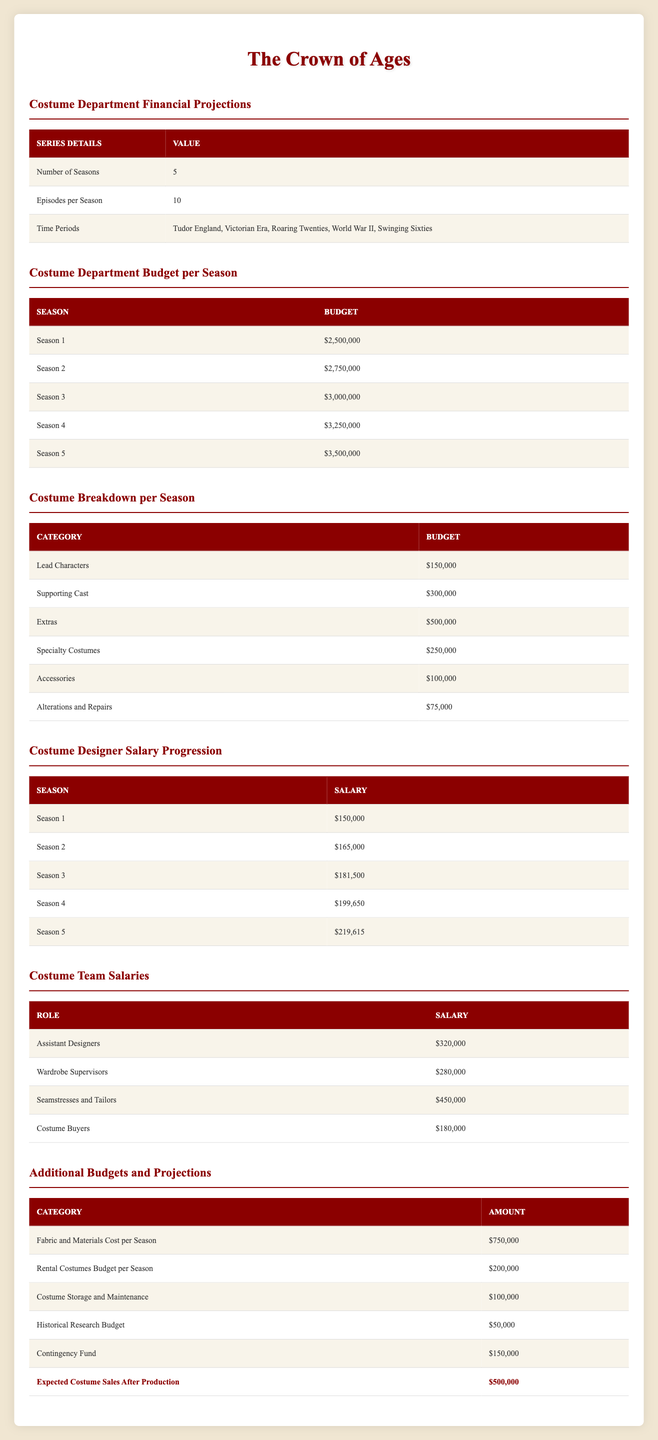What is the total budget for the costume department across all five seasons? To find the total budget, we need to sum the budgets for each season: 2,500,000 + 2,750,000 + 3,000,000 + 3,250,000 + 3,500,000. This results in 15,000,000.
Answer: 15,000,000 What is the expected costume designer salary for Season 4? The salary for the costume designer in Season 4 is clearly stated in the table. It is 199,650.
Answer: 199,650 Is the budget for fabric and materials cost per season greater than the historical research budget? The budget for fabric and materials per season is 750,000, while the historical research budget is 50,000. Since 750,000 is greater than 50,000, the answer is yes.
Answer: Yes What is the difference in budget from Season 1 to Season 5 for the costume department? To find the difference, we subtract the budget of Season 1 from Season 5: 3,500,000 - 2,500,000 = 1,000,000.
Answer: 1,000,000 What percentage of the total budget for Season 3 is allocated to the supporting cast's costumes? The budget for Season 3 is 3,000,000, and the amount allocated to supporting cast costumes is 300,000. The percentage is calculated as (300,000 / 3,000,000) * 100, which equals 10%.
Answer: 10% What is the total budget for the costume storage and maintenance across all seasons? The budget for costume storage and maintenance is listed as 100,000, and since it's a flat amount per season, across 5 seasons, the total remains 100,000.
Answer: 100,000 Which role has the highest salary in the costume team? Comparing the salaries of the roles listed: Assistant Designers (320,000), Wardrobe Supervisors (280,000), Seamstresses and Tailors (450,000), and Costume Buyers (180,000), the highest salary is for Seamstresses and Tailors at 450,000.
Answer: 450,000 How much is allocated for alterations and repairs for the entire series? The amount for alterations and repairs per season is 75,000, so for 5 seasons, we calculate: 75,000 * 5 = 375,000.
Answer: 375,000 